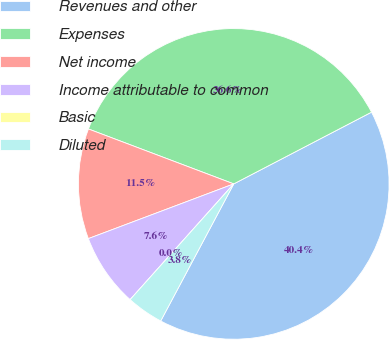Convert chart. <chart><loc_0><loc_0><loc_500><loc_500><pie_chart><fcel>Revenues and other<fcel>Expenses<fcel>Net income<fcel>Income attributable to common<fcel>Basic<fcel>Diluted<nl><fcel>40.43%<fcel>36.61%<fcel>11.48%<fcel>7.65%<fcel>0.0%<fcel>3.83%<nl></chart> 